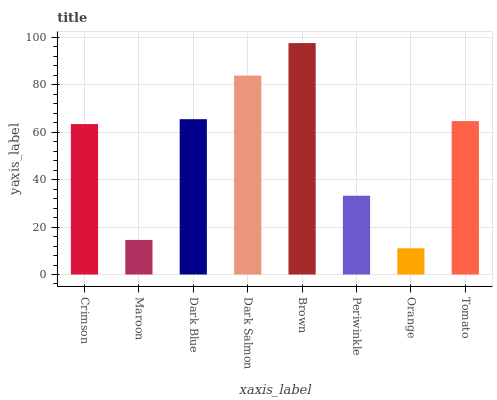Is Orange the minimum?
Answer yes or no. Yes. Is Brown the maximum?
Answer yes or no. Yes. Is Maroon the minimum?
Answer yes or no. No. Is Maroon the maximum?
Answer yes or no. No. Is Crimson greater than Maroon?
Answer yes or no. Yes. Is Maroon less than Crimson?
Answer yes or no. Yes. Is Maroon greater than Crimson?
Answer yes or no. No. Is Crimson less than Maroon?
Answer yes or no. No. Is Tomato the high median?
Answer yes or no. Yes. Is Crimson the low median?
Answer yes or no. Yes. Is Dark Blue the high median?
Answer yes or no. No. Is Orange the low median?
Answer yes or no. No. 